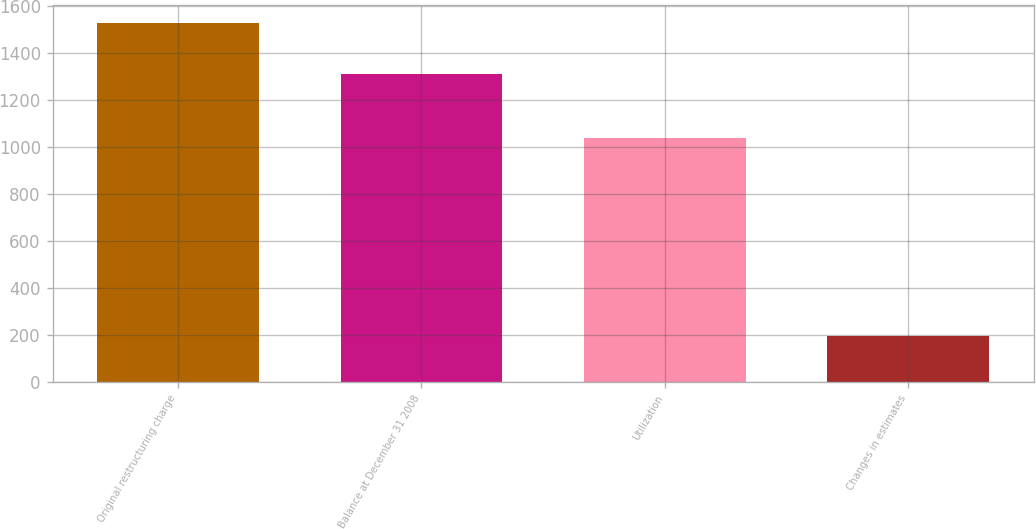Convert chart to OTSL. <chart><loc_0><loc_0><loc_500><loc_500><bar_chart><fcel>Original restructuring charge<fcel>Balance at December 31 2008<fcel>Utilization<fcel>Changes in estimates<nl><fcel>1530<fcel>1311<fcel>1037<fcel>196<nl></chart> 